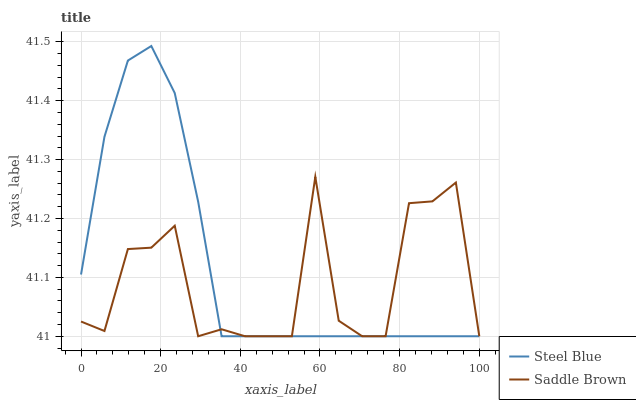Does Saddle Brown have the minimum area under the curve?
Answer yes or no. Yes. Does Saddle Brown have the maximum area under the curve?
Answer yes or no. No. Is Saddle Brown the roughest?
Answer yes or no. Yes. Is Saddle Brown the smoothest?
Answer yes or no. No. Does Saddle Brown have the highest value?
Answer yes or no. No. 